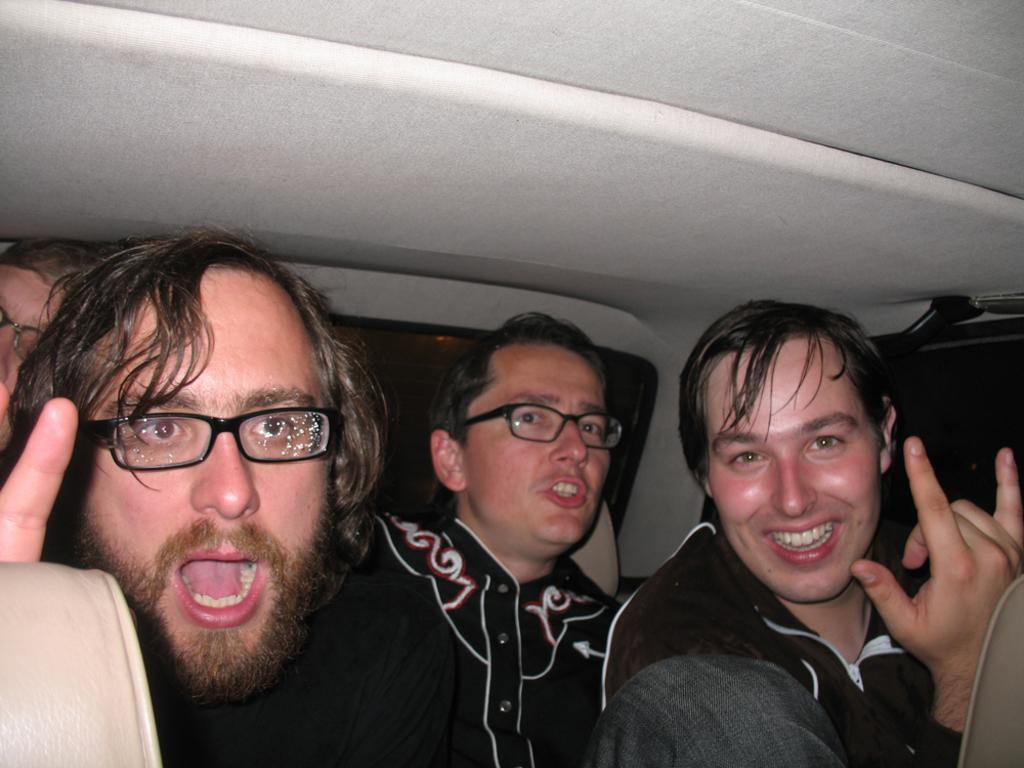What is happening in the image involving the group of people? The people in the image are smiling. Can you describe any specific features of the people in the image? Three of the people are wearing spectacles. What might suggest that the people are in a specific location or setting? The people appear to be sitting in a vehicle. What type of jam is being spread on the plastic coal in the image? There is no jam, plastic, or coal present in the image. 